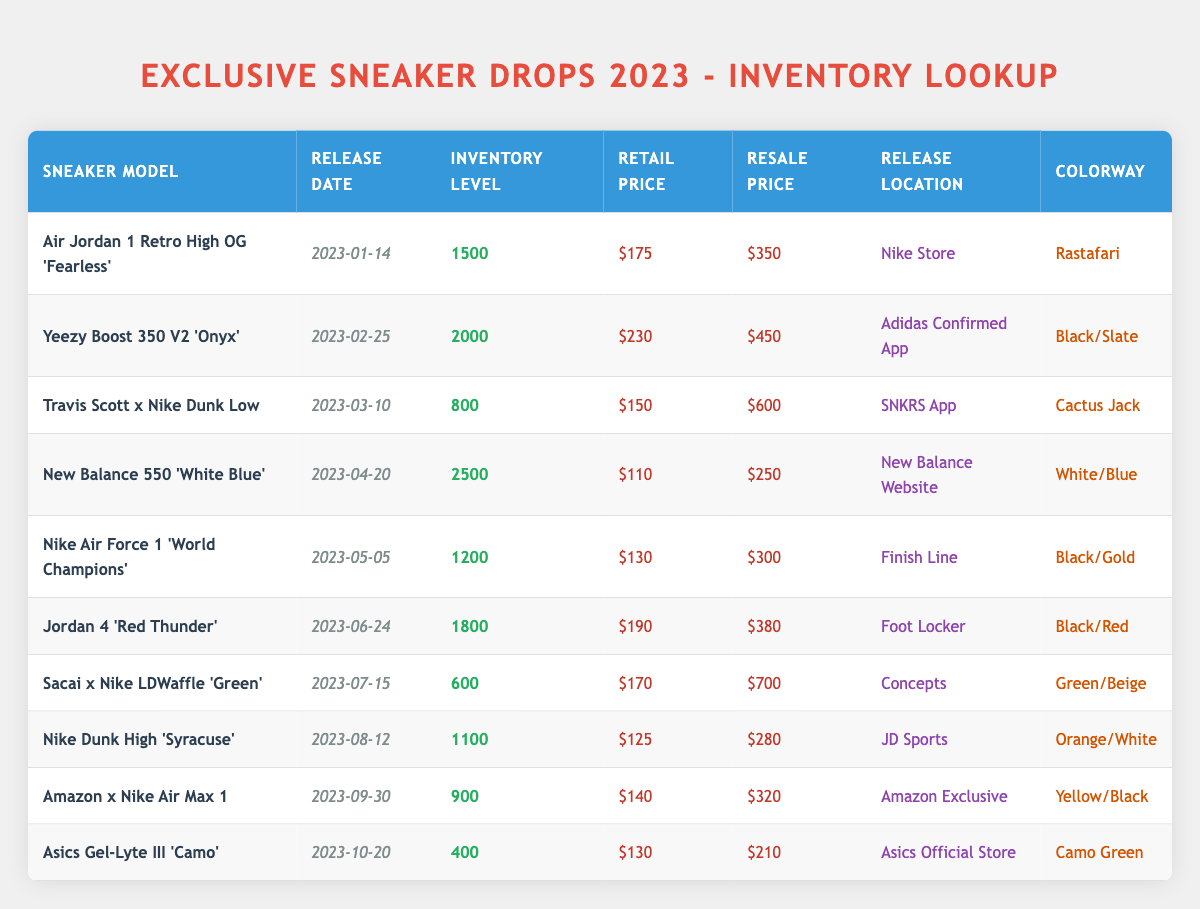What is the release date of the "Travis Scott x Nike Dunk Low"? The release date can be found in the corresponding row for the sneaker model "Travis Scott x Nike Dunk Low". It is listed as "2023-03-10".
Answer: 2023-03-10 How many inventory levels were produced for the "Nike Dunk High 'Syracuse'"? By locating the row for "Nike Dunk High 'Syracuse'", we can see that the inventory level recorded is 1100.
Answer: 1100 Which sneaker had the highest resale price and what was that price? To find this, we compare the resale prices of all sneakers listed in the table. The highest value is $700 for the "Sacai x Nike LDWaffle 'Green'".
Answer: $700 What is the total inventory of all sneakers released in 2023? We add the inventory levels of each sneaker from the table: 1500 + 2000 + 800 + 2500 + 1200 + 1800 + 600 + 1100 + 900 + 400 = 11800. The total inventory is therefore 11800.
Answer: 11800 Is the retail price of "Jordan 4 'Red Thunder'" higher than $200? The retail price for "Jordan 4 'Red Thunder'" is $190, which is less than $200.
Answer: No How many sneakers had a resale price greater than $400? We review the resale prices: "Travis Scott x Nike Dunk Low" ($600), "Yeezy Boost 350 V2 'Onyx'" ($450), and "Sacai x Nike LDWaffle 'Green'" ($700). That gives us a total of three sneakers with resale prices over $400.
Answer: 3 What is the difference between the retail price and resale price for "New Balance 550 'White Blue'"? For "New Balance 550 'White Blue'", the retail price is $110 and the resale price is $250. The difference is $250 - $110 = $140.
Answer: $140 Which sneaker model has the lowest inventory level and what is that level? By checking the inventory levels of all models, "Asics Gel-Lyte III 'Camo'" has the lowest inventory at 400.
Answer: 400 What was the release location for the "Amazon x Nike Air Max 1"? Looking at the row for "Amazon x Nike Air Max 1", the release location is "Amazon Exclusive".
Answer: Amazon Exclusive 